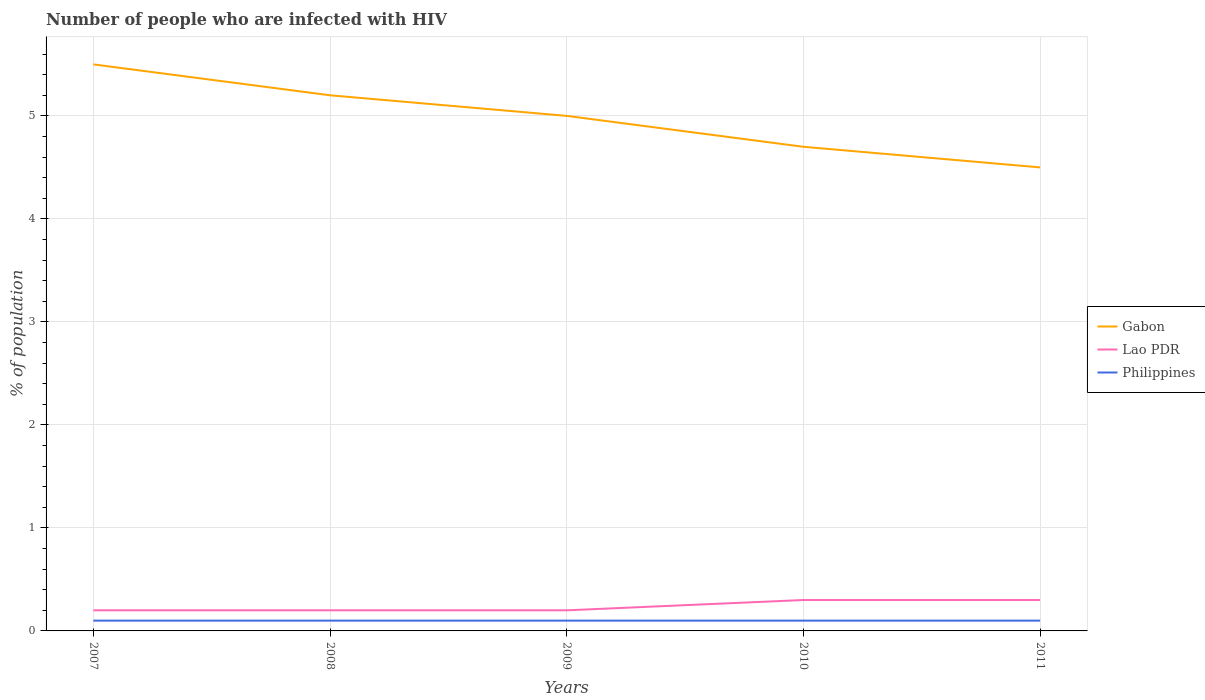Does the line corresponding to Gabon intersect with the line corresponding to Philippines?
Offer a very short reply. No. Is the number of lines equal to the number of legend labels?
Keep it short and to the point. Yes. In which year was the percentage of HIV infected population in in Gabon maximum?
Give a very brief answer. 2011. What is the total percentage of HIV infected population in in Philippines in the graph?
Your answer should be very brief. 0. What is the difference between the highest and the lowest percentage of HIV infected population in in Lao PDR?
Your response must be concise. 2. How many years are there in the graph?
Make the answer very short. 5. What is the difference between two consecutive major ticks on the Y-axis?
Provide a succinct answer. 1. Are the values on the major ticks of Y-axis written in scientific E-notation?
Make the answer very short. No. How many legend labels are there?
Your answer should be very brief. 3. How are the legend labels stacked?
Offer a very short reply. Vertical. What is the title of the graph?
Keep it short and to the point. Number of people who are infected with HIV. Does "Israel" appear as one of the legend labels in the graph?
Offer a terse response. No. What is the label or title of the Y-axis?
Ensure brevity in your answer.  % of population. What is the % of population in Lao PDR in 2007?
Offer a terse response. 0.2. What is the % of population of Philippines in 2007?
Offer a very short reply. 0.1. What is the % of population in Gabon in 2008?
Offer a terse response. 5.2. What is the % of population of Gabon in 2009?
Your answer should be compact. 5. What is the % of population of Gabon in 2010?
Keep it short and to the point. 4.7. What is the % of population of Lao PDR in 2010?
Ensure brevity in your answer.  0.3. What is the % of population of Philippines in 2010?
Your answer should be compact. 0.1. What is the % of population of Gabon in 2011?
Provide a short and direct response. 4.5. What is the % of population of Lao PDR in 2011?
Ensure brevity in your answer.  0.3. Across all years, what is the maximum % of population of Lao PDR?
Your answer should be compact. 0.3. Across all years, what is the minimum % of population of Gabon?
Your answer should be compact. 4.5. Across all years, what is the minimum % of population of Lao PDR?
Offer a terse response. 0.2. What is the total % of population of Gabon in the graph?
Your response must be concise. 24.9. What is the total % of population of Lao PDR in the graph?
Your response must be concise. 1.2. What is the total % of population of Philippines in the graph?
Provide a succinct answer. 0.5. What is the difference between the % of population of Philippines in 2007 and that in 2008?
Provide a succinct answer. 0. What is the difference between the % of population of Lao PDR in 2007 and that in 2009?
Provide a succinct answer. 0. What is the difference between the % of population in Gabon in 2007 and that in 2010?
Give a very brief answer. 0.8. What is the difference between the % of population in Philippines in 2007 and that in 2010?
Ensure brevity in your answer.  0. What is the difference between the % of population of Philippines in 2007 and that in 2011?
Offer a terse response. 0. What is the difference between the % of population of Gabon in 2008 and that in 2009?
Provide a short and direct response. 0.2. What is the difference between the % of population in Lao PDR in 2008 and that in 2009?
Offer a very short reply. 0. What is the difference between the % of population of Gabon in 2008 and that in 2010?
Make the answer very short. 0.5. What is the difference between the % of population of Lao PDR in 2008 and that in 2010?
Make the answer very short. -0.1. What is the difference between the % of population of Philippines in 2008 and that in 2010?
Your answer should be compact. 0. What is the difference between the % of population of Gabon in 2008 and that in 2011?
Provide a succinct answer. 0.7. What is the difference between the % of population of Lao PDR in 2008 and that in 2011?
Give a very brief answer. -0.1. What is the difference between the % of population in Lao PDR in 2009 and that in 2011?
Offer a terse response. -0.1. What is the difference between the % of population of Lao PDR in 2010 and that in 2011?
Provide a succinct answer. 0. What is the difference between the % of population of Philippines in 2010 and that in 2011?
Your answer should be compact. 0. What is the difference between the % of population in Lao PDR in 2007 and the % of population in Philippines in 2008?
Ensure brevity in your answer.  0.1. What is the difference between the % of population of Gabon in 2007 and the % of population of Philippines in 2009?
Provide a succinct answer. 5.4. What is the difference between the % of population of Lao PDR in 2007 and the % of population of Philippines in 2009?
Keep it short and to the point. 0.1. What is the difference between the % of population in Gabon in 2007 and the % of population in Philippines in 2010?
Offer a very short reply. 5.4. What is the difference between the % of population in Lao PDR in 2007 and the % of population in Philippines in 2011?
Offer a terse response. 0.1. What is the difference between the % of population in Gabon in 2008 and the % of population in Lao PDR in 2009?
Offer a terse response. 5. What is the difference between the % of population in Gabon in 2008 and the % of population in Philippines in 2009?
Provide a succinct answer. 5.1. What is the difference between the % of population of Gabon in 2008 and the % of population of Lao PDR in 2010?
Your answer should be compact. 4.9. What is the difference between the % of population in Gabon in 2008 and the % of population in Philippines in 2011?
Your answer should be compact. 5.1. What is the difference between the % of population in Lao PDR in 2008 and the % of population in Philippines in 2011?
Keep it short and to the point. 0.1. What is the difference between the % of population in Gabon in 2009 and the % of population in Philippines in 2010?
Your response must be concise. 4.9. What is the difference between the % of population in Lao PDR in 2009 and the % of population in Philippines in 2010?
Keep it short and to the point. 0.1. What is the difference between the % of population of Lao PDR in 2009 and the % of population of Philippines in 2011?
Keep it short and to the point. 0.1. What is the difference between the % of population in Gabon in 2010 and the % of population in Lao PDR in 2011?
Your response must be concise. 4.4. What is the difference between the % of population in Gabon in 2010 and the % of population in Philippines in 2011?
Offer a terse response. 4.6. What is the difference between the % of population in Lao PDR in 2010 and the % of population in Philippines in 2011?
Your answer should be very brief. 0.2. What is the average % of population of Gabon per year?
Your response must be concise. 4.98. What is the average % of population of Lao PDR per year?
Give a very brief answer. 0.24. In the year 2008, what is the difference between the % of population in Gabon and % of population in Lao PDR?
Your response must be concise. 5. In the year 2009, what is the difference between the % of population of Gabon and % of population of Philippines?
Your answer should be very brief. 4.9. In the year 2010, what is the difference between the % of population of Lao PDR and % of population of Philippines?
Keep it short and to the point. 0.2. What is the ratio of the % of population of Gabon in 2007 to that in 2008?
Your answer should be compact. 1.06. What is the ratio of the % of population in Gabon in 2007 to that in 2010?
Your response must be concise. 1.17. What is the ratio of the % of population of Lao PDR in 2007 to that in 2010?
Your answer should be very brief. 0.67. What is the ratio of the % of population in Gabon in 2007 to that in 2011?
Offer a terse response. 1.22. What is the ratio of the % of population of Philippines in 2007 to that in 2011?
Give a very brief answer. 1. What is the ratio of the % of population in Gabon in 2008 to that in 2009?
Keep it short and to the point. 1.04. What is the ratio of the % of population in Gabon in 2008 to that in 2010?
Keep it short and to the point. 1.11. What is the ratio of the % of population of Lao PDR in 2008 to that in 2010?
Your answer should be compact. 0.67. What is the ratio of the % of population of Gabon in 2008 to that in 2011?
Provide a succinct answer. 1.16. What is the ratio of the % of population of Gabon in 2009 to that in 2010?
Your response must be concise. 1.06. What is the ratio of the % of population in Philippines in 2009 to that in 2010?
Provide a succinct answer. 1. What is the ratio of the % of population in Lao PDR in 2009 to that in 2011?
Offer a very short reply. 0.67. What is the ratio of the % of population in Philippines in 2009 to that in 2011?
Your answer should be very brief. 1. What is the ratio of the % of population of Gabon in 2010 to that in 2011?
Your answer should be very brief. 1.04. What is the difference between the highest and the lowest % of population in Gabon?
Provide a short and direct response. 1. 